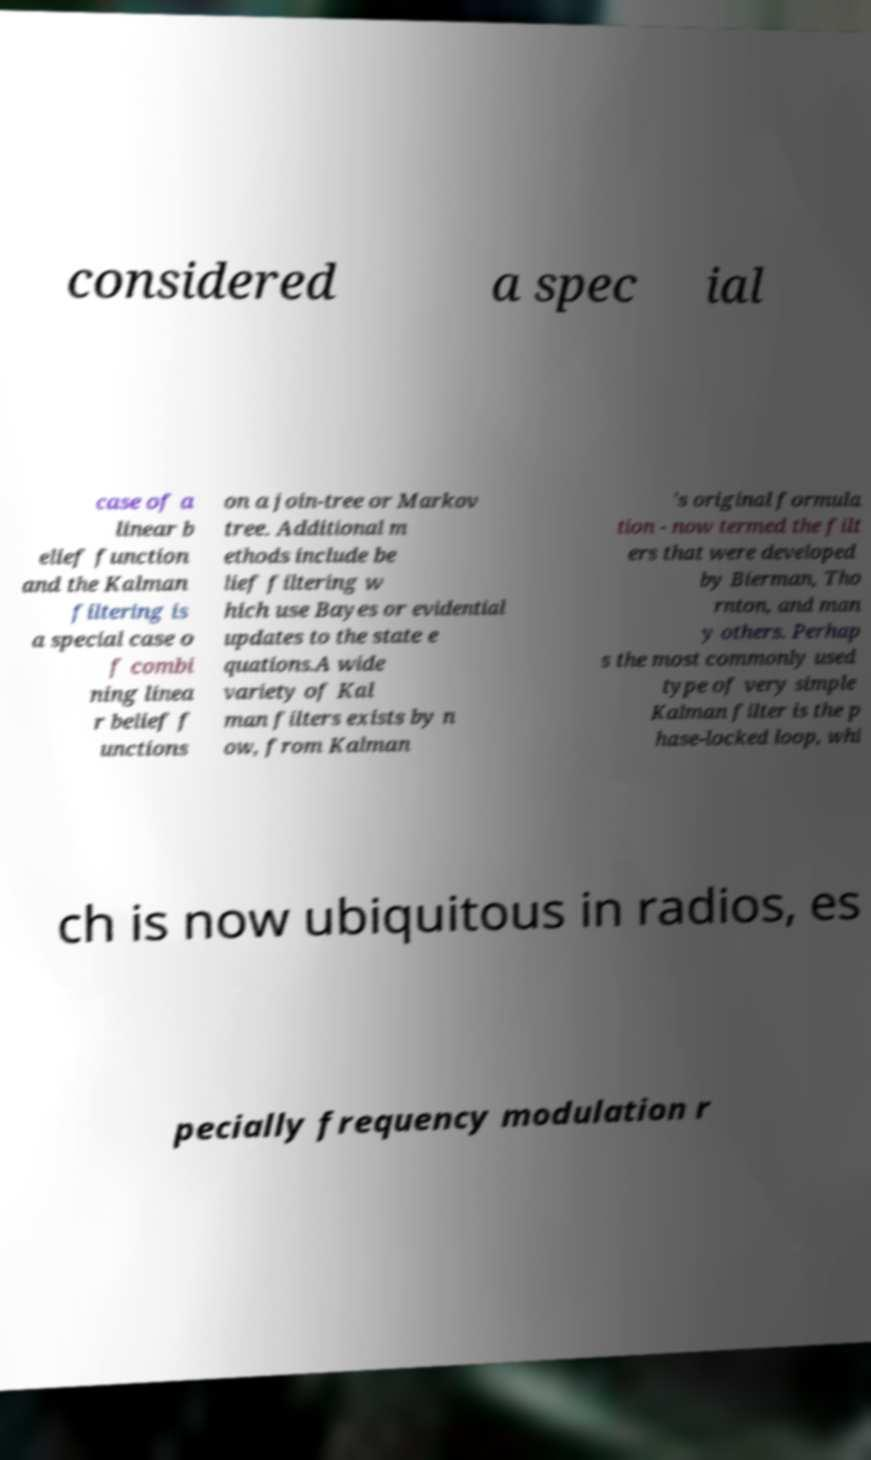What messages or text are displayed in this image? I need them in a readable, typed format. considered a spec ial case of a linear b elief function and the Kalman filtering is a special case o f combi ning linea r belief f unctions on a join-tree or Markov tree. Additional m ethods include be lief filtering w hich use Bayes or evidential updates to the state e quations.A wide variety of Kal man filters exists by n ow, from Kalman 's original formula tion - now termed the filt ers that were developed by Bierman, Tho rnton, and man y others. Perhap s the most commonly used type of very simple Kalman filter is the p hase-locked loop, whi ch is now ubiquitous in radios, es pecially frequency modulation r 